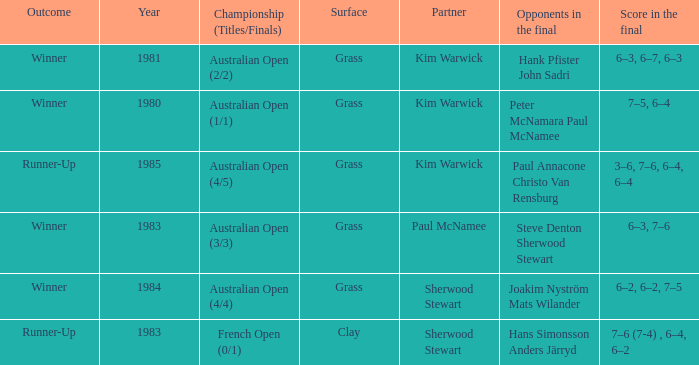What championship was played in 1981? Australian Open (2/2). 